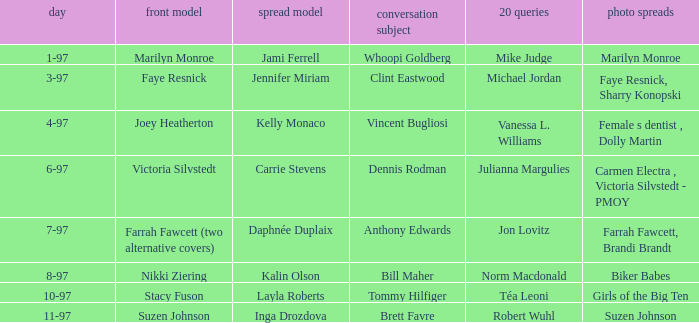Who was the centerfold model when a pictorial was done on marilyn monroe? Jami Ferrell. 